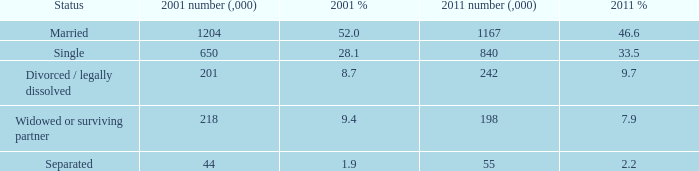What is the lowest 2011 number (,000)? 55.0. 